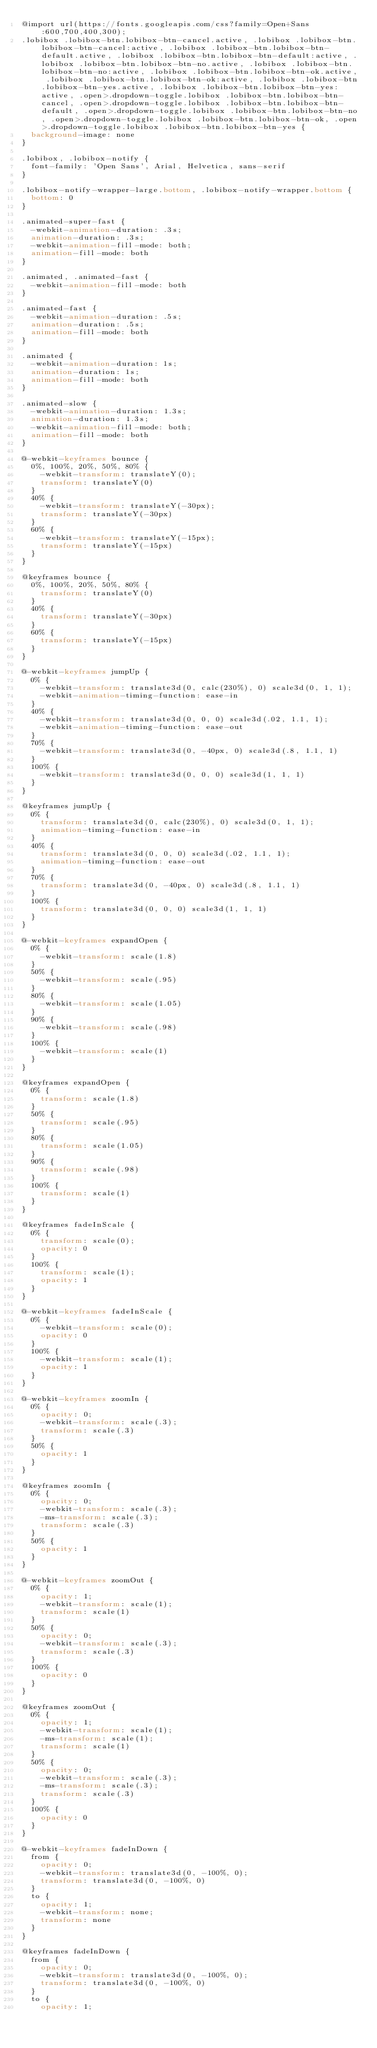Convert code to text. <code><loc_0><loc_0><loc_500><loc_500><_CSS_>@import url(https://fonts.googleapis.com/css?family=Open+Sans:600,700,400,300);
.lobibox .lobibox-btn.lobibox-btn-cancel.active, .lobibox .lobibox-btn.lobibox-btn-cancel:active, .lobibox .lobibox-btn.lobibox-btn-default.active, .lobibox .lobibox-btn.lobibox-btn-default:active, .lobibox .lobibox-btn.lobibox-btn-no.active, .lobibox .lobibox-btn.lobibox-btn-no:active, .lobibox .lobibox-btn.lobibox-btn-ok.active, .lobibox .lobibox-btn.lobibox-btn-ok:active, .lobibox .lobibox-btn.lobibox-btn-yes.active, .lobibox .lobibox-btn.lobibox-btn-yes:active, .open>.dropdown-toggle.lobibox .lobibox-btn.lobibox-btn-cancel, .open>.dropdown-toggle.lobibox .lobibox-btn.lobibox-btn-default, .open>.dropdown-toggle.lobibox .lobibox-btn.lobibox-btn-no, .open>.dropdown-toggle.lobibox .lobibox-btn.lobibox-btn-ok, .open>.dropdown-toggle.lobibox .lobibox-btn.lobibox-btn-yes {
	background-image: none
}

.lobibox, .lobibox-notify {
	font-family: 'Open Sans', Arial, Helvetica, sans-serif
}

.lobibox-notify-wrapper-large.bottom, .lobibox-notify-wrapper.bottom {
	bottom: 0
}

.animated-super-fast {
	-webkit-animation-duration: .3s;
	animation-duration: .3s;
	-webkit-animation-fill-mode: both;
	animation-fill-mode: both
}

.animated, .animated-fast {
	-webkit-animation-fill-mode: both
}

.animated-fast {
	-webkit-animation-duration: .5s;
	animation-duration: .5s;
	animation-fill-mode: both
}

.animated {
	-webkit-animation-duration: 1s;
	animation-duration: 1s;
	animation-fill-mode: both
}

.animated-slow {
	-webkit-animation-duration: 1.3s;
	animation-duration: 1.3s;
	-webkit-animation-fill-mode: both;
	animation-fill-mode: both
}

@-webkit-keyframes bounce {
	0%, 100%, 20%, 50%, 80% {
		-webkit-transform: translateY(0);
		transform: translateY(0)
	}
	40% {
		-webkit-transform: translateY(-30px);
		transform: translateY(-30px)
	}
	60% {
		-webkit-transform: translateY(-15px);
		transform: translateY(-15px)
	}
}

@keyframes bounce {
	0%, 100%, 20%, 50%, 80% {
		transform: translateY(0)
	}
	40% {
		transform: translateY(-30px)
	}
	60% {
		transform: translateY(-15px)
	}
}

@-webkit-keyframes jumpUp {
	0% {
		-webkit-transform: translate3d(0, calc(230%), 0) scale3d(0, 1, 1);
		-webkit-animation-timing-function: ease-in
	}
	40% {
		-webkit-transform: translate3d(0, 0, 0) scale3d(.02, 1.1, 1);
		-webkit-animation-timing-function: ease-out
	}
	70% {
		-webkit-transform: translate3d(0, -40px, 0) scale3d(.8, 1.1, 1)
	}
	100% {
		-webkit-transform: translate3d(0, 0, 0) scale3d(1, 1, 1)
	}
}

@keyframes jumpUp {
	0% {
		transform: translate3d(0, calc(230%), 0) scale3d(0, 1, 1);
		animation-timing-function: ease-in
	}
	40% {
		transform: translate3d(0, 0, 0) scale3d(.02, 1.1, 1);
		animation-timing-function: ease-out
	}
	70% {
		transform: translate3d(0, -40px, 0) scale3d(.8, 1.1, 1)
	}
	100% {
		transform: translate3d(0, 0, 0) scale3d(1, 1, 1)
	}
}

@-webkit-keyframes expandOpen {
	0% {
		-webkit-transform: scale(1.8)
	}
	50% {
		-webkit-transform: scale(.95)
	}
	80% {
		-webkit-transform: scale(1.05)
	}
	90% {
		-webkit-transform: scale(.98)
	}
	100% {
		-webkit-transform: scale(1)
	}
}

@keyframes expandOpen {
	0% {
		transform: scale(1.8)
	}
	50% {
		transform: scale(.95)
	}
	80% {
		transform: scale(1.05)
	}
	90% {
		transform: scale(.98)
	}
	100% {
		transform: scale(1)
	}
}

@keyframes fadeInScale {
	0% {
		transform: scale(0);
		opacity: 0
	}
	100% {
		transform: scale(1);
		opacity: 1
	}
}

@-webkit-keyframes fadeInScale {
	0% {
		-webkit-transform: scale(0);
		opacity: 0
	}
	100% {
		-webkit-transform: scale(1);
		opacity: 1
	}
}

@-webkit-keyframes zoomIn {
	0% {
		opacity: 0;
		-webkit-transform: scale(.3);
		transform: scale(.3)
	}
	50% {
		opacity: 1
	}
}

@keyframes zoomIn {
	0% {
		opacity: 0;
		-webkit-transform: scale(.3);
		-ms-transform: scale(.3);
		transform: scale(.3)
	}
	50% {
		opacity: 1
	}
}

@-webkit-keyframes zoomOut {
	0% {
		opacity: 1;
		-webkit-transform: scale(1);
		transform: scale(1)
	}
	50% {
		opacity: 0;
		-webkit-transform: scale(.3);
		transform: scale(.3)
	}
	100% {
		opacity: 0
	}
}

@keyframes zoomOut {
	0% {
		opacity: 1;
		-webkit-transform: scale(1);
		-ms-transform: scale(1);
		transform: scale(1)
	}
	50% {
		opacity: 0;
		-webkit-transform: scale(.3);
		-ms-transform: scale(.3);
		transform: scale(.3)
	}
	100% {
		opacity: 0
	}
}

@-webkit-keyframes fadeInDown {
	from {
		opacity: 0;
		-webkit-transform: translate3d(0, -100%, 0);
		transform: translate3d(0, -100%, 0)
	}
	to {
		opacity: 1;
		-webkit-transform: none;
		transform: none
	}
}

@keyframes fadeInDown {
	from {
		opacity: 0;
		-webkit-transform: translate3d(0, -100%, 0);
		transform: translate3d(0, -100%, 0)
	}
	to {
		opacity: 1;</code> 